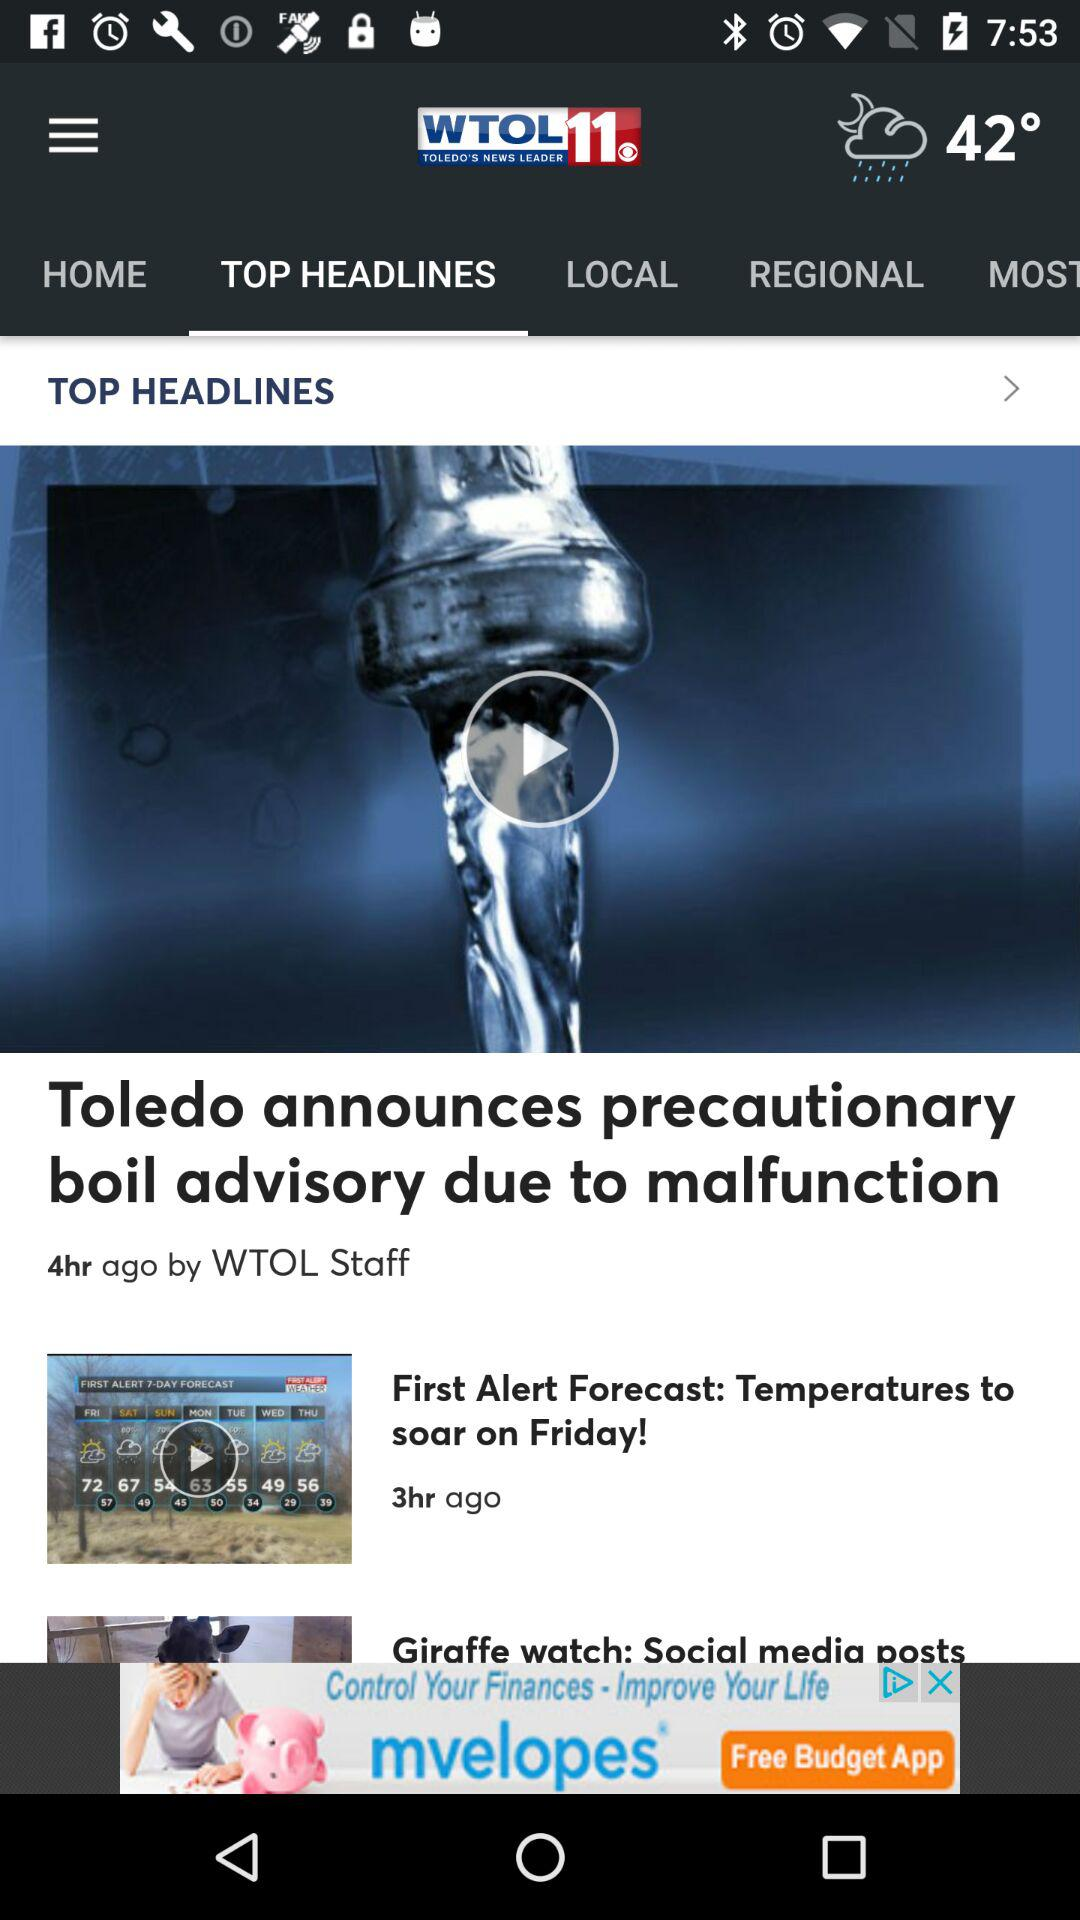What is the temperature? The temperature is 42°. 